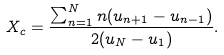<formula> <loc_0><loc_0><loc_500><loc_500>X _ { c } = \frac { \sum _ { n = 1 } ^ { N } n ( u _ { n + 1 } - u _ { n - 1 } ) } { 2 ( u _ { N } - u _ { 1 } ) } .</formula> 